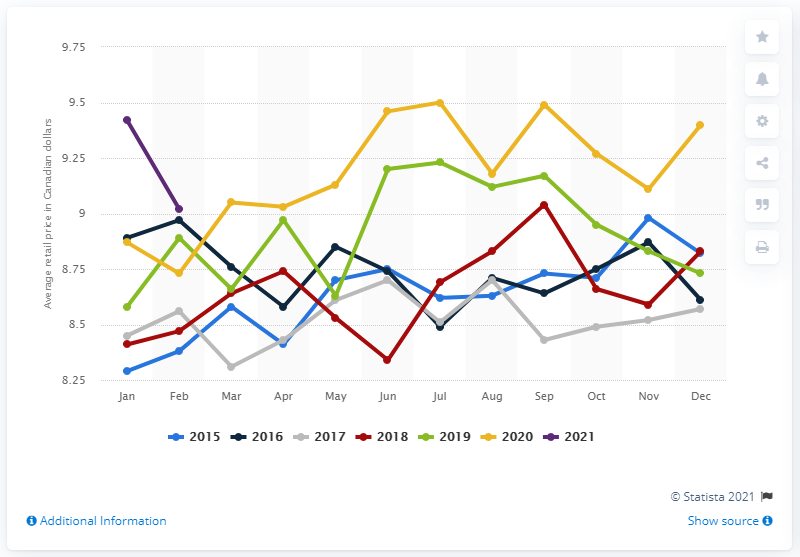List a handful of essential elements in this visual. In February 2021, the average retail price for a kilogram of mushrooms was 9.02 dollars. 